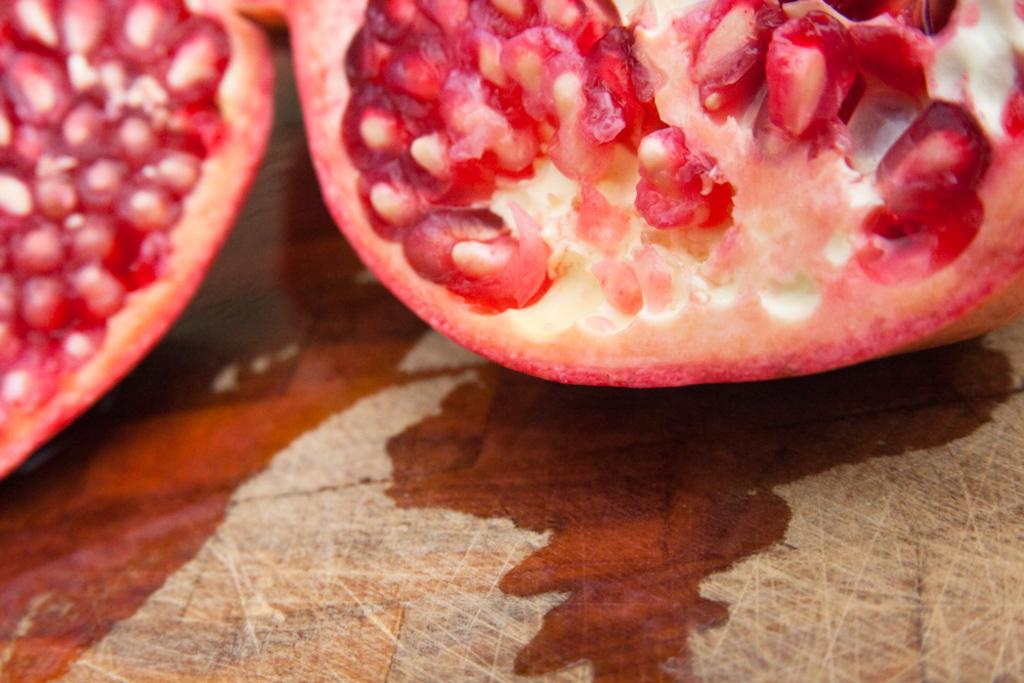What type of fruit is visible in the image? There are pomegranate cut fruit in the image. Where are the pomegranate cut fruit located? The pomegranate cut fruit is on a surface. Can you describe the position of the surface in the image? The surface is in the foreground of the image. What type of wound can be seen on the pomegranate in the image? There is no wound visible on the pomegranate in the image; it is simply cut fruit. 